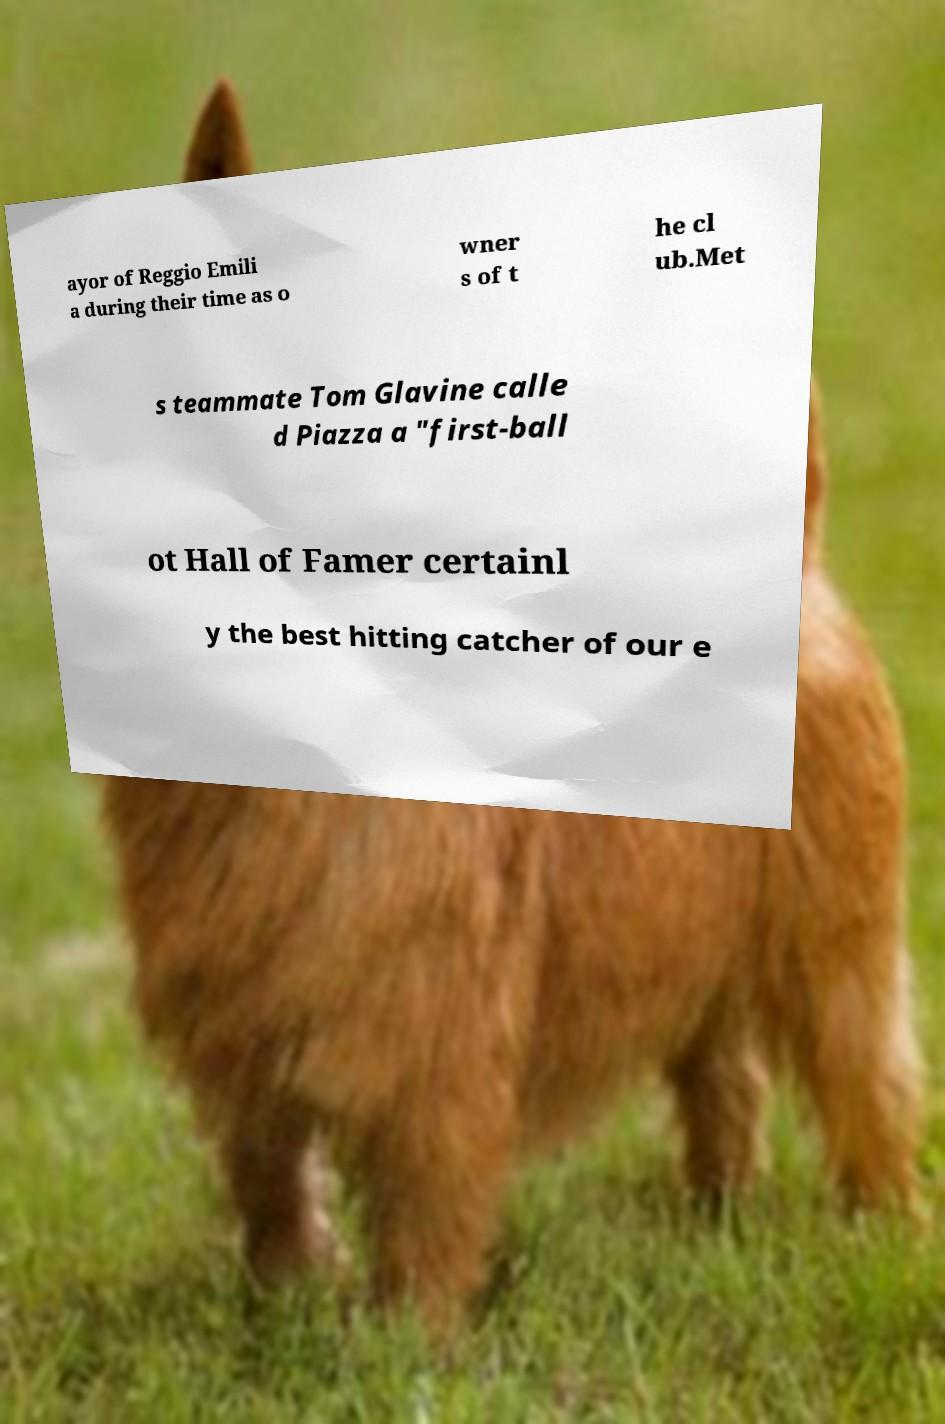What messages or text are displayed in this image? I need them in a readable, typed format. ayor of Reggio Emili a during their time as o wner s of t he cl ub.Met s teammate Tom Glavine calle d Piazza a "first-ball ot Hall of Famer certainl y the best hitting catcher of our e 